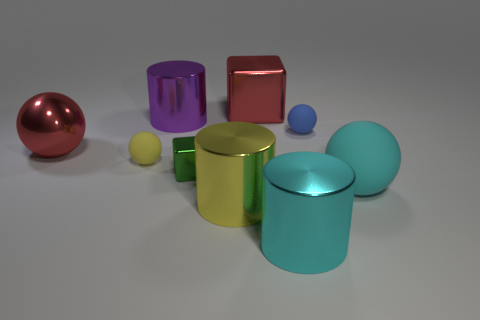There is a metallic thing behind the purple metallic cylinder; does it have the same color as the large sphere to the left of the cyan shiny cylinder?
Offer a terse response. Yes. Are there any cyan things of the same size as the purple cylinder?
Your response must be concise. Yes. There is a big object that is both in front of the small blue matte thing and behind the big rubber thing; what material is it?
Provide a succinct answer. Metal. How many rubber objects are purple things or big red objects?
Ensure brevity in your answer.  0. The purple object that is the same material as the red cube is what shape?
Your answer should be compact. Cylinder. What number of big things are in front of the big block and left of the cyan sphere?
Give a very brief answer. 4. What is the size of the metallic thing in front of the big yellow shiny cylinder?
Offer a very short reply. Large. How many other objects are the same color as the small metal object?
Give a very brief answer. 0. There is a large sphere that is behind the cyan thing that is on the right side of the cyan cylinder; what is it made of?
Offer a terse response. Metal. Do the small ball left of the blue rubber object and the metal sphere have the same color?
Provide a succinct answer. No. 